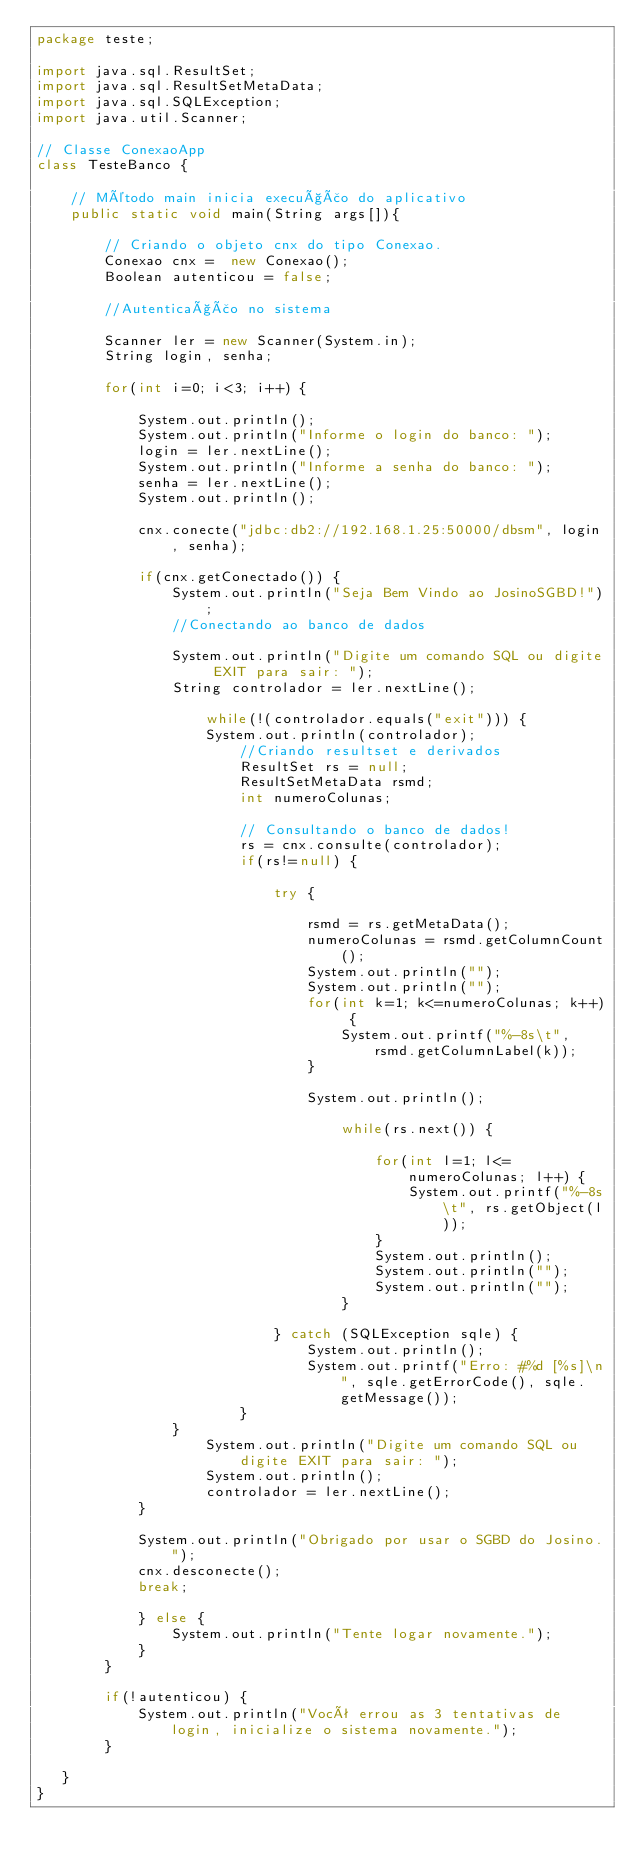<code> <loc_0><loc_0><loc_500><loc_500><_Java_>package teste;

import java.sql.ResultSet;
import java.sql.ResultSetMetaData;
import java.sql.SQLException;
import java.util.Scanner;

// Classe ConexaoApp
class TesteBanco {

	// Método main inicia execução do aplicativo
	public static void main(String args[]){
		
		// Criando o objeto cnx do tipo Conexao.
		Conexao cnx =  new Conexao();
		Boolean autenticou = false;
		
		//Autenticação no sistema
		
		Scanner ler = new Scanner(System.in);
		String login, senha;
		
		for(int i=0; i<3; i++) {
			
			System.out.println();
			System.out.println("Informe o login do banco: ");
			login = ler.nextLine();
			System.out.println("Informe a senha do banco: ");
			senha = ler.nextLine();
			System.out.println();

			cnx.conecte("jdbc:db2://192.168.1.25:50000/dbsm", login, senha);		
			
			if(cnx.getConectado()) {
				System.out.println("Seja Bem Vindo ao JosinoSGBD!");
				//Conectando ao banco de dados
				
				System.out.println("Digite um comando SQL ou digite EXIT para sair: ");
				String controlador = ler.nextLine();
				
					while(!(controlador.equals("exit"))) {
					System.out.println(controlador);
						//Criando resultset e derivados
						ResultSet rs = null;
						ResultSetMetaData rsmd;
						int numeroColunas;
						
						// Consultando o banco de dados!
						rs = cnx.consulte(controlador);
						if(rs!=null) {
						
							try {
							
								rsmd = rs.getMetaData();
								numeroColunas = rsmd.getColumnCount();
								System.out.println("");
								System.out.println("");
								for(int k=1; k<=numeroColunas; k++) {
									System.out.printf("%-8s\t", rsmd.getColumnLabel(k));
								}
							
								System.out.println();
								
									while(rs.next()) {
	
										for(int l=1; l<=numeroColunas; l++) {
											System.out.printf("%-8s\t", rs.getObject(l));	
										}
										System.out.println();
										System.out.println("");
										System.out.println("");
									}
							
							} catch (SQLException sqle) {
								System.out.println();
								System.out.printf("Erro: #%d [%s]\n", sqle.getErrorCode(), sqle.getMessage());
						}
				}
					System.out.println("Digite um comando SQL ou digite EXIT para sair: ");
					System.out.println();
					controlador = ler.nextLine();
			}
				
			System.out.println("Obrigado por usar o SGBD do Josino.");
			cnx.desconecte();
		    break;
		    	
			} else {
				System.out.println("Tente logar novamente.");
			}
		}	
		
		if(!autenticou) {
			System.out.println("Você errou as 3 tentativas de login, inicialize o sistema novamente.");		
		}
		
   } 
}


</code> 